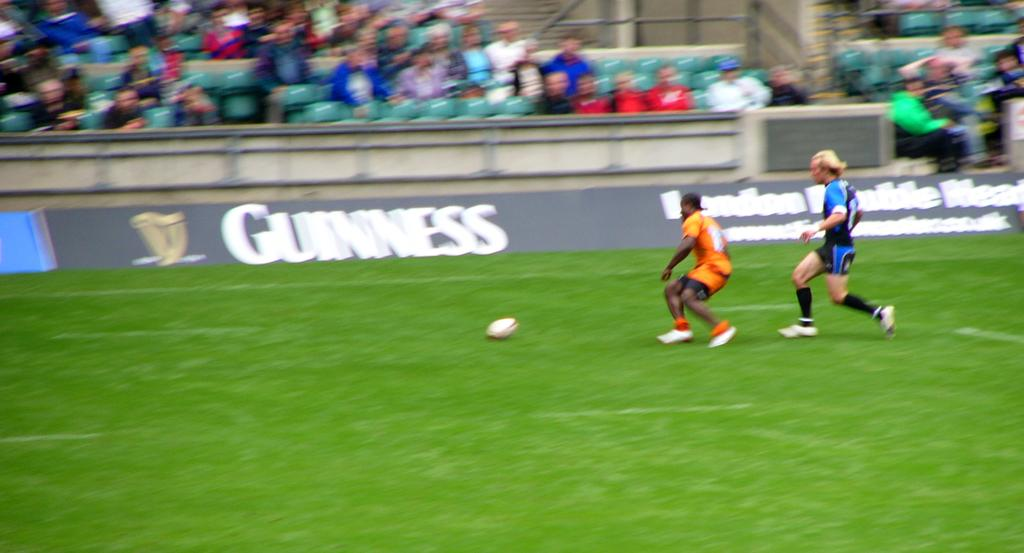<image>
Offer a succinct explanation of the picture presented. A competitive soccer match that was sponsored by Guinness. 